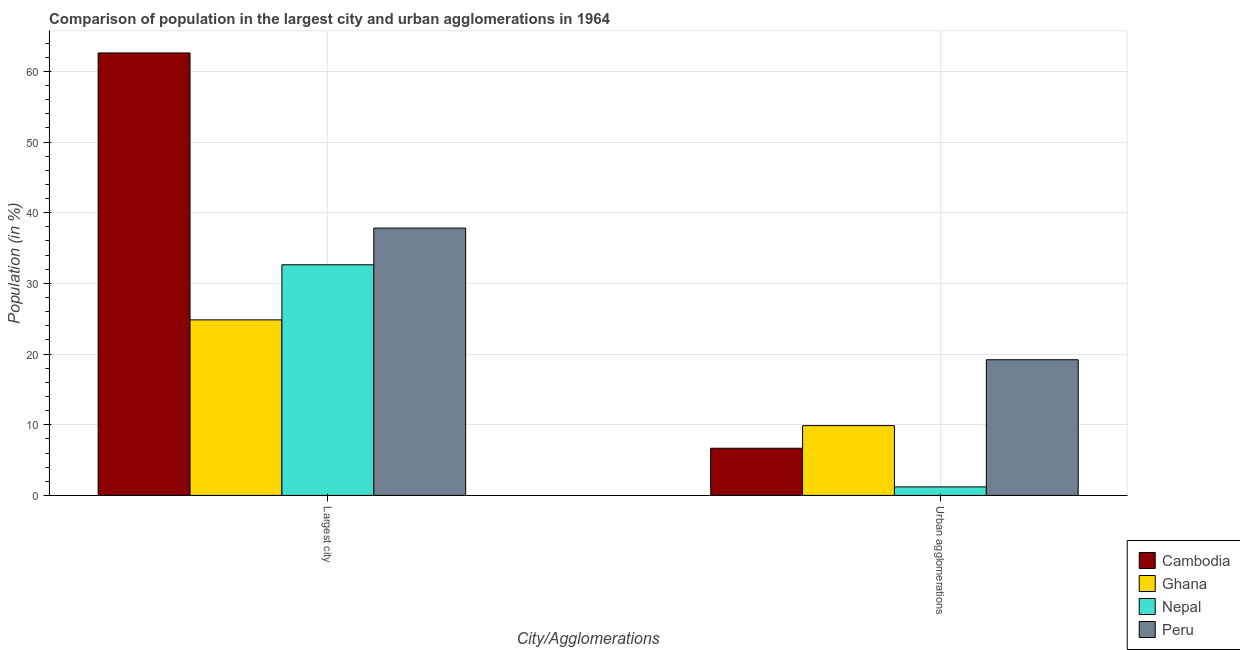How many groups of bars are there?
Provide a succinct answer. 2. What is the label of the 1st group of bars from the left?
Provide a succinct answer. Largest city. What is the population in urban agglomerations in Ghana?
Make the answer very short. 9.87. Across all countries, what is the maximum population in the largest city?
Provide a short and direct response. 62.6. Across all countries, what is the minimum population in the largest city?
Give a very brief answer. 24.84. In which country was the population in the largest city maximum?
Provide a short and direct response. Cambodia. What is the total population in the largest city in the graph?
Your answer should be very brief. 157.89. What is the difference between the population in urban agglomerations in Peru and that in Cambodia?
Offer a very short reply. 12.52. What is the difference between the population in urban agglomerations in Nepal and the population in the largest city in Cambodia?
Keep it short and to the point. -61.39. What is the average population in urban agglomerations per country?
Your answer should be compact. 9.24. What is the difference between the population in urban agglomerations and population in the largest city in Ghana?
Your answer should be compact. -14.96. What is the ratio of the population in urban agglomerations in Cambodia to that in Ghana?
Your answer should be very brief. 0.68. Is the population in urban agglomerations in Nepal less than that in Cambodia?
Make the answer very short. Yes. In how many countries, is the population in urban agglomerations greater than the average population in urban agglomerations taken over all countries?
Provide a short and direct response. 2. What does the 3rd bar from the left in Largest city represents?
Make the answer very short. Nepal. Are all the bars in the graph horizontal?
Offer a very short reply. No. How many countries are there in the graph?
Your answer should be compact. 4. What is the difference between two consecutive major ticks on the Y-axis?
Make the answer very short. 10. Are the values on the major ticks of Y-axis written in scientific E-notation?
Provide a short and direct response. No. Does the graph contain any zero values?
Offer a very short reply. No. Where does the legend appear in the graph?
Give a very brief answer. Bottom right. What is the title of the graph?
Offer a terse response. Comparison of population in the largest city and urban agglomerations in 1964. Does "Bermuda" appear as one of the legend labels in the graph?
Make the answer very short. No. What is the label or title of the X-axis?
Ensure brevity in your answer.  City/Agglomerations. What is the Population (in %) in Cambodia in Largest city?
Provide a succinct answer. 62.6. What is the Population (in %) of Ghana in Largest city?
Provide a succinct answer. 24.84. What is the Population (in %) in Nepal in Largest city?
Offer a very short reply. 32.63. What is the Population (in %) in Peru in Largest city?
Provide a succinct answer. 37.82. What is the Population (in %) in Cambodia in Urban agglomerations?
Your answer should be very brief. 6.67. What is the Population (in %) of Ghana in Urban agglomerations?
Provide a succinct answer. 9.87. What is the Population (in %) in Nepal in Urban agglomerations?
Keep it short and to the point. 1.21. What is the Population (in %) of Peru in Urban agglomerations?
Provide a short and direct response. 19.2. Across all City/Agglomerations, what is the maximum Population (in %) in Cambodia?
Keep it short and to the point. 62.6. Across all City/Agglomerations, what is the maximum Population (in %) in Ghana?
Your answer should be very brief. 24.84. Across all City/Agglomerations, what is the maximum Population (in %) of Nepal?
Your response must be concise. 32.63. Across all City/Agglomerations, what is the maximum Population (in %) of Peru?
Your answer should be compact. 37.82. Across all City/Agglomerations, what is the minimum Population (in %) in Cambodia?
Your answer should be compact. 6.67. Across all City/Agglomerations, what is the minimum Population (in %) of Ghana?
Your answer should be compact. 9.87. Across all City/Agglomerations, what is the minimum Population (in %) in Nepal?
Ensure brevity in your answer.  1.21. Across all City/Agglomerations, what is the minimum Population (in %) in Peru?
Offer a very short reply. 19.2. What is the total Population (in %) of Cambodia in the graph?
Your response must be concise. 69.28. What is the total Population (in %) of Ghana in the graph?
Your answer should be very brief. 34.71. What is the total Population (in %) in Nepal in the graph?
Offer a terse response. 33.84. What is the total Population (in %) of Peru in the graph?
Provide a short and direct response. 57.02. What is the difference between the Population (in %) of Cambodia in Largest city and that in Urban agglomerations?
Give a very brief answer. 55.93. What is the difference between the Population (in %) in Ghana in Largest city and that in Urban agglomerations?
Your answer should be very brief. 14.96. What is the difference between the Population (in %) in Nepal in Largest city and that in Urban agglomerations?
Provide a succinct answer. 31.42. What is the difference between the Population (in %) of Peru in Largest city and that in Urban agglomerations?
Offer a terse response. 18.63. What is the difference between the Population (in %) in Cambodia in Largest city and the Population (in %) in Ghana in Urban agglomerations?
Provide a short and direct response. 52.73. What is the difference between the Population (in %) of Cambodia in Largest city and the Population (in %) of Nepal in Urban agglomerations?
Ensure brevity in your answer.  61.39. What is the difference between the Population (in %) of Cambodia in Largest city and the Population (in %) of Peru in Urban agglomerations?
Your response must be concise. 43.4. What is the difference between the Population (in %) of Ghana in Largest city and the Population (in %) of Nepal in Urban agglomerations?
Ensure brevity in your answer.  23.63. What is the difference between the Population (in %) of Ghana in Largest city and the Population (in %) of Peru in Urban agglomerations?
Provide a short and direct response. 5.64. What is the difference between the Population (in %) in Nepal in Largest city and the Population (in %) in Peru in Urban agglomerations?
Make the answer very short. 13.43. What is the average Population (in %) of Cambodia per City/Agglomerations?
Provide a succinct answer. 34.64. What is the average Population (in %) in Ghana per City/Agglomerations?
Offer a terse response. 17.35. What is the average Population (in %) in Nepal per City/Agglomerations?
Your answer should be compact. 16.92. What is the average Population (in %) of Peru per City/Agglomerations?
Your answer should be very brief. 28.51. What is the difference between the Population (in %) of Cambodia and Population (in %) of Ghana in Largest city?
Your response must be concise. 37.76. What is the difference between the Population (in %) of Cambodia and Population (in %) of Nepal in Largest city?
Ensure brevity in your answer.  29.97. What is the difference between the Population (in %) of Cambodia and Population (in %) of Peru in Largest city?
Give a very brief answer. 24.78. What is the difference between the Population (in %) of Ghana and Population (in %) of Nepal in Largest city?
Your response must be concise. -7.79. What is the difference between the Population (in %) in Ghana and Population (in %) in Peru in Largest city?
Give a very brief answer. -12.99. What is the difference between the Population (in %) in Nepal and Population (in %) in Peru in Largest city?
Your response must be concise. -5.19. What is the difference between the Population (in %) in Cambodia and Population (in %) in Ghana in Urban agglomerations?
Your answer should be very brief. -3.2. What is the difference between the Population (in %) of Cambodia and Population (in %) of Nepal in Urban agglomerations?
Make the answer very short. 5.47. What is the difference between the Population (in %) of Cambodia and Population (in %) of Peru in Urban agglomerations?
Make the answer very short. -12.52. What is the difference between the Population (in %) of Ghana and Population (in %) of Nepal in Urban agglomerations?
Offer a very short reply. 8.67. What is the difference between the Population (in %) in Ghana and Population (in %) in Peru in Urban agglomerations?
Offer a very short reply. -9.32. What is the difference between the Population (in %) of Nepal and Population (in %) of Peru in Urban agglomerations?
Make the answer very short. -17.99. What is the ratio of the Population (in %) in Cambodia in Largest city to that in Urban agglomerations?
Offer a terse response. 9.38. What is the ratio of the Population (in %) in Ghana in Largest city to that in Urban agglomerations?
Offer a very short reply. 2.52. What is the ratio of the Population (in %) of Nepal in Largest city to that in Urban agglomerations?
Offer a terse response. 27.06. What is the ratio of the Population (in %) in Peru in Largest city to that in Urban agglomerations?
Offer a very short reply. 1.97. What is the difference between the highest and the second highest Population (in %) in Cambodia?
Your response must be concise. 55.93. What is the difference between the highest and the second highest Population (in %) of Ghana?
Your answer should be compact. 14.96. What is the difference between the highest and the second highest Population (in %) of Nepal?
Provide a short and direct response. 31.42. What is the difference between the highest and the second highest Population (in %) in Peru?
Provide a succinct answer. 18.63. What is the difference between the highest and the lowest Population (in %) in Cambodia?
Provide a short and direct response. 55.93. What is the difference between the highest and the lowest Population (in %) in Ghana?
Make the answer very short. 14.96. What is the difference between the highest and the lowest Population (in %) in Nepal?
Give a very brief answer. 31.42. What is the difference between the highest and the lowest Population (in %) of Peru?
Ensure brevity in your answer.  18.63. 